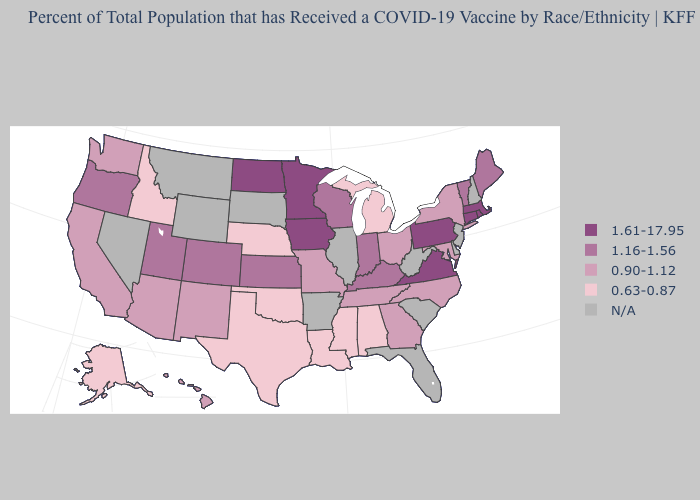Among the states that border Maryland , which have the lowest value?
Give a very brief answer. Pennsylvania, Virginia. Does Iowa have the highest value in the MidWest?
Short answer required. Yes. Does Connecticut have the lowest value in the USA?
Keep it brief. No. Which states have the lowest value in the USA?
Give a very brief answer. Alabama, Alaska, Idaho, Louisiana, Michigan, Mississippi, Nebraska, Oklahoma, Texas. What is the value of Massachusetts?
Short answer required. 1.61-17.95. Name the states that have a value in the range 0.90-1.12?
Be succinct. Arizona, California, Georgia, Hawaii, Maryland, Missouri, New Mexico, New York, North Carolina, Ohio, Tennessee, Washington. Is the legend a continuous bar?
Write a very short answer. No. What is the highest value in the USA?
Be succinct. 1.61-17.95. Which states have the lowest value in the USA?
Be succinct. Alabama, Alaska, Idaho, Louisiana, Michigan, Mississippi, Nebraska, Oklahoma, Texas. How many symbols are there in the legend?
Write a very short answer. 5. Does the map have missing data?
Write a very short answer. Yes. Does Colorado have the highest value in the West?
Concise answer only. Yes. What is the value of South Dakota?
Quick response, please. N/A. What is the lowest value in the West?
Short answer required. 0.63-0.87. Name the states that have a value in the range 0.90-1.12?
Keep it brief. Arizona, California, Georgia, Hawaii, Maryland, Missouri, New Mexico, New York, North Carolina, Ohio, Tennessee, Washington. 